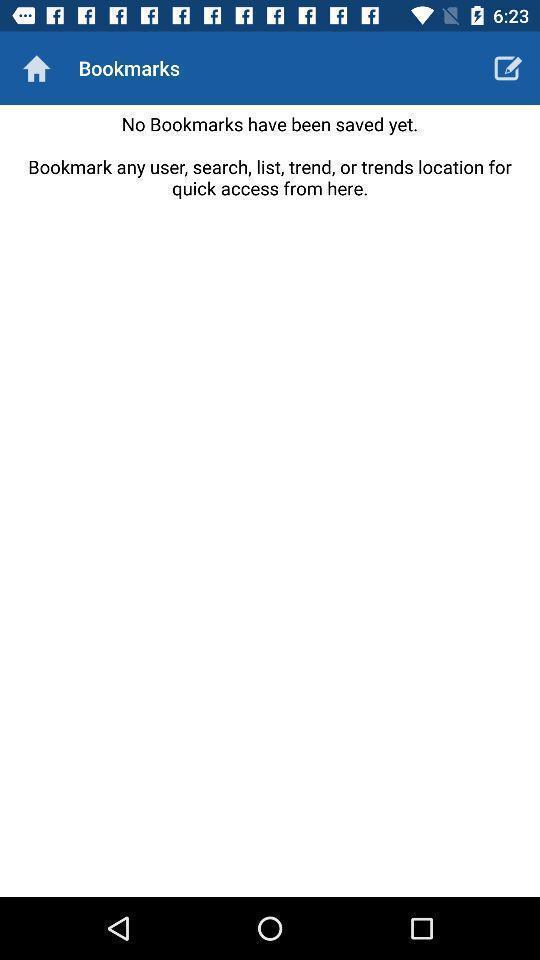Give me a summary of this screen capture. Screen displaying blank page in bookmarks. 